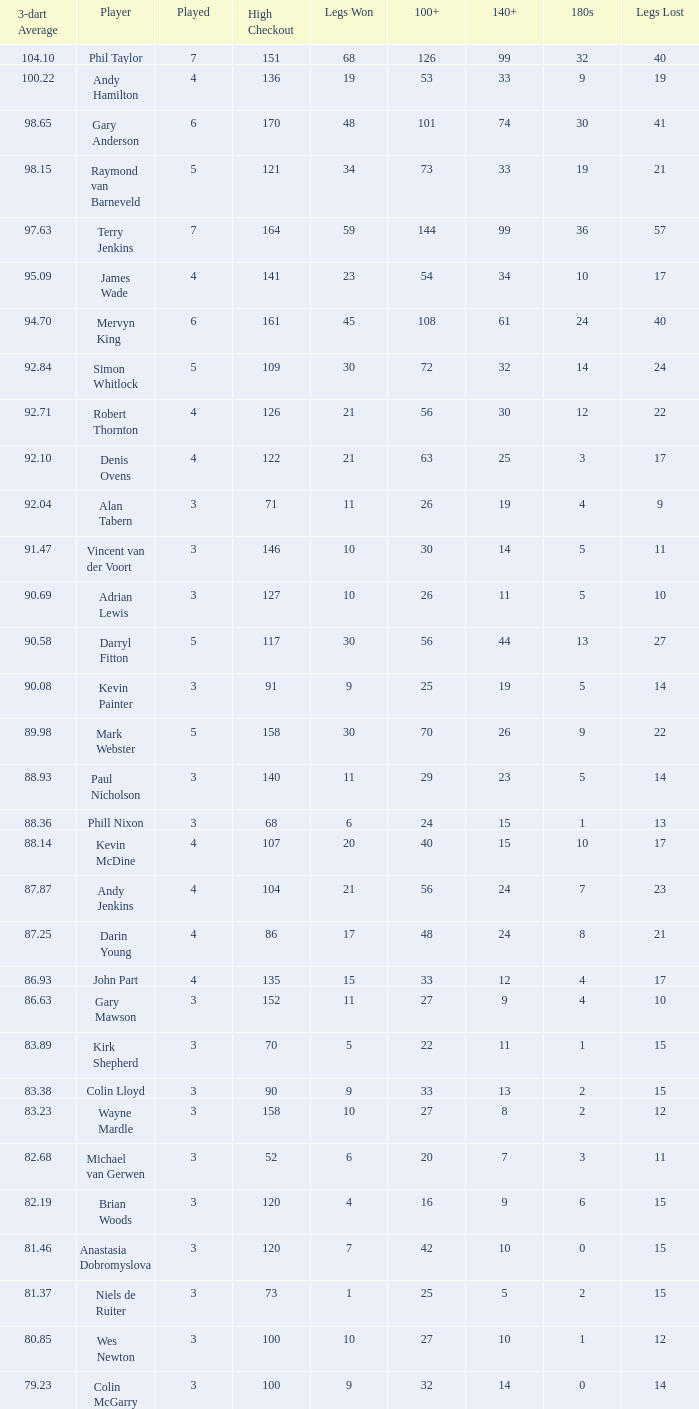What is the played number when the high checkout is 135? 4.0. 